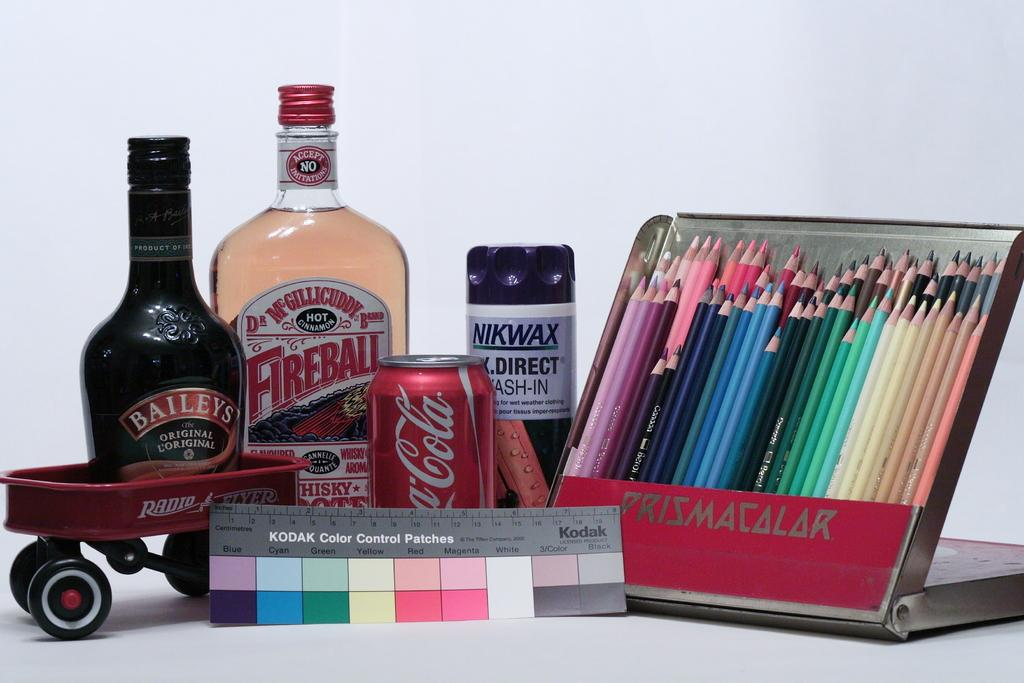<image>
Present a compact description of the photo's key features. a bottle of fireball whiskey next to a can of coke and some colored pencils 